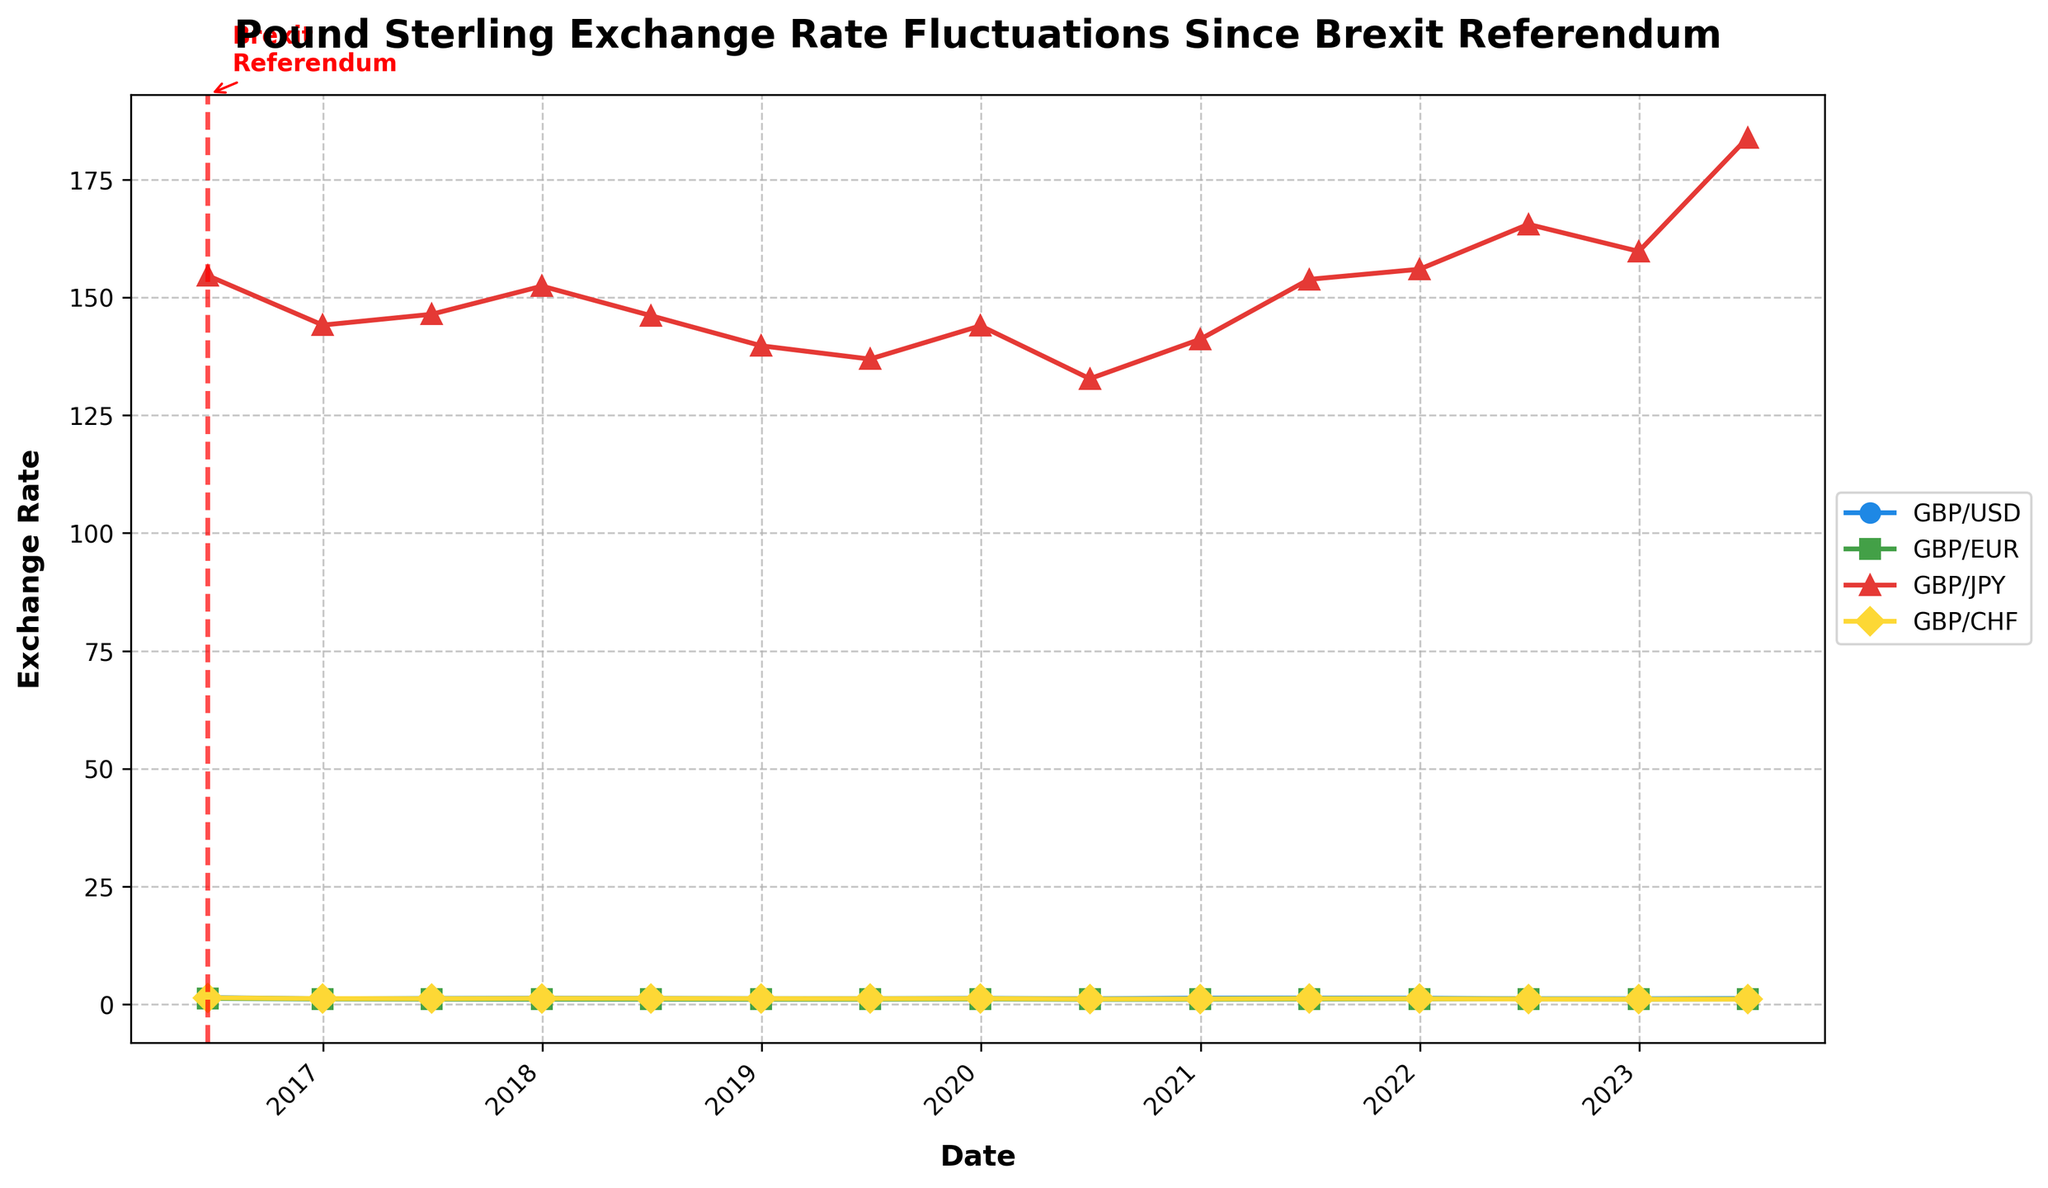What is the overall trend of the GBP/USD exchange rate from the Brexit referendum to 2023? The line for GBP/USD shows an initial decline after the Brexit referendum in 2016, followed by some fluctuations where it increases and decreases, but it ends on a higher note in 2023 compared to its lowest points immediately post-referendum.
Answer: Fluctuates but generally increases How did the GBP/EUR exchange rate perform in the year following the Brexit referendum? Looking at the GBP/EUR line from June 2016 to June 2017, we observe a decline from roughly 1.3072 to 1.1371.
Answer: Decreased Which exchange rate had the highest fluctuation over the given period? By observing the distance between the highest and lowest points of each line, GBP/JPY (shown in red) had the highest fluctuation, ranging from around 132.74 to 183.85.
Answer: GBP/JPY On which date did the GBP/USD exchange rate hit its peak, and what was the value? The highest point on the GBP/USD line appears to be around December 2020, where the value is approximately 1.3672.
Answer: December 2020, 1.3672 Which exchange rate showed the least variation over the period? GBP/CHF, indicated by a yellow line, shows the least variation, maintaining a relatively stable range throughout the period.
Answer: GBP/CHF By how much did the GBP/JPY exchange rate change from December 2022 to June 2023? From the figure, the GBP/JPY exchange rate increased from around 159.75 in December 2022 to approximately 183.85 in June 2023. The change is 183.85 - 159.75.
Answer: 24.10 Which exchange rate line is depicted using green markers? Visually, the green markers correspond to the GBP/EUR exchange rate.
Answer: GBP/EUR Compare the GBP/EUR and GBP/CHF rates at the end of 2021. Which one is higher? The line for GBP/EUR at the end of 2021 (around 1.1910) is compared to the line for GBP/CHF at the same time (about 1.2341). GBP/CHF is higher than GBP/EUR at that point.
Answer: GBP/CHF How did the GBP/USD exchange rate trend compare with GBP/EUR from 2017 to 2019? From 2017 to 2019, the GBP/USD shows an increasing trend with a peak around December 2019 whereas GBP/EUR follows a relatively stable pattern with minor fluctuations, slightly increasing towards the end of 2019.
Answer: GBP/USD had a more pronounced increase What is notable about the exchange rate trends immediately following the Brexit referendum in June 2016? Immediately following the Brexit referendum, all four exchange rates exhibit a significant drop, indicating a sharp devaluation of the Pound Sterling across major currencies.
Answer: Sharp drop in all rates 